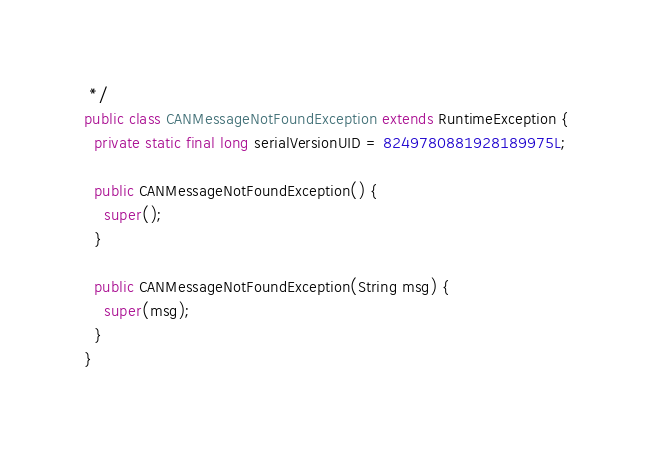Convert code to text. <code><loc_0><loc_0><loc_500><loc_500><_Java_> */
public class CANMessageNotFoundException extends RuntimeException {
  private static final long serialVersionUID = 8249780881928189975L;

  public CANMessageNotFoundException() {
    super();
  }

  public CANMessageNotFoundException(String msg) {
    super(msg);
  }
}
</code> 